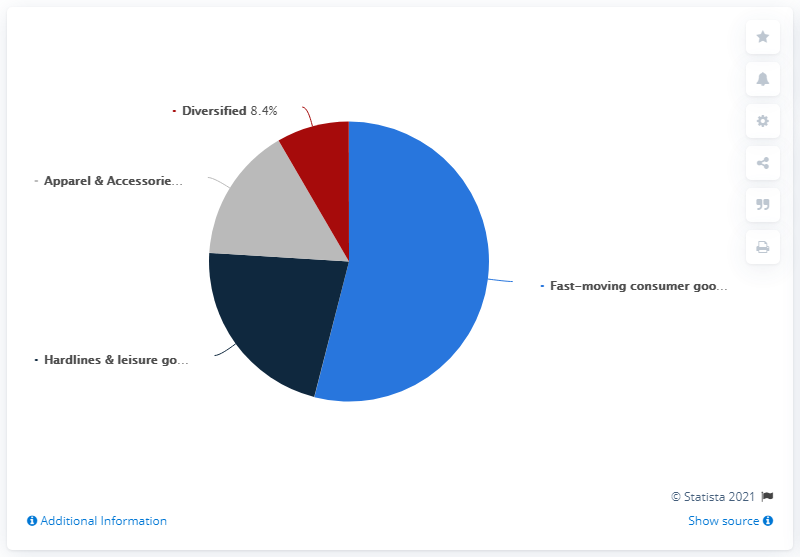Give some essential details in this illustration. The least value, which is 8.4, indicates a certain percentage. Grey indicates apparel and accessories in the context of the query. 